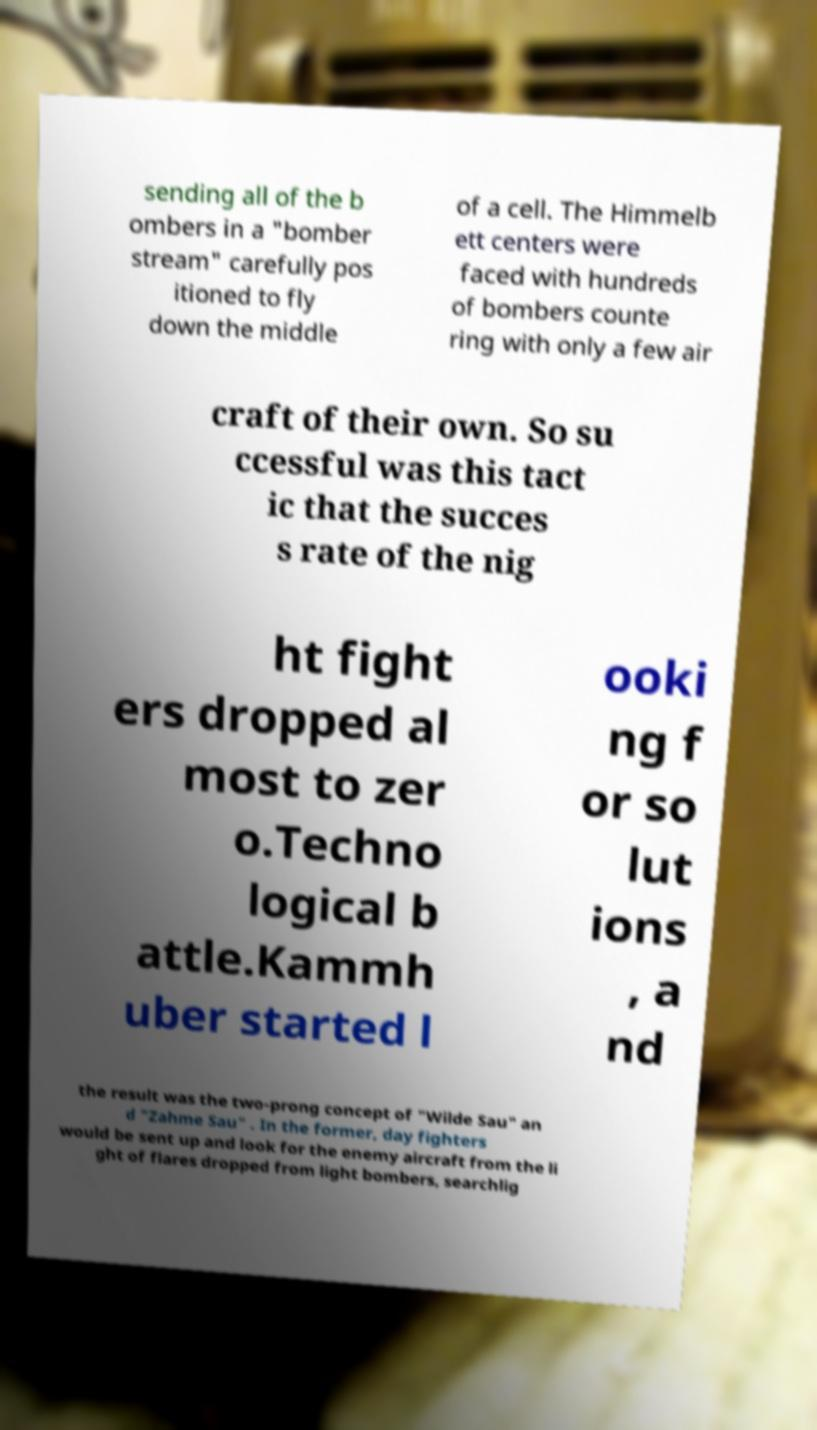Could you assist in decoding the text presented in this image and type it out clearly? sending all of the b ombers in a "bomber stream" carefully pos itioned to fly down the middle of a cell. The Himmelb ett centers were faced with hundreds of bombers counte ring with only a few air craft of their own. So su ccessful was this tact ic that the succes s rate of the nig ht fight ers dropped al most to zer o.Techno logical b attle.Kammh uber started l ooki ng f or so lut ions , a nd the result was the two-prong concept of "Wilde Sau" an d "Zahme Sau" . In the former, day fighters would be sent up and look for the enemy aircraft from the li ght of flares dropped from light bombers, searchlig 